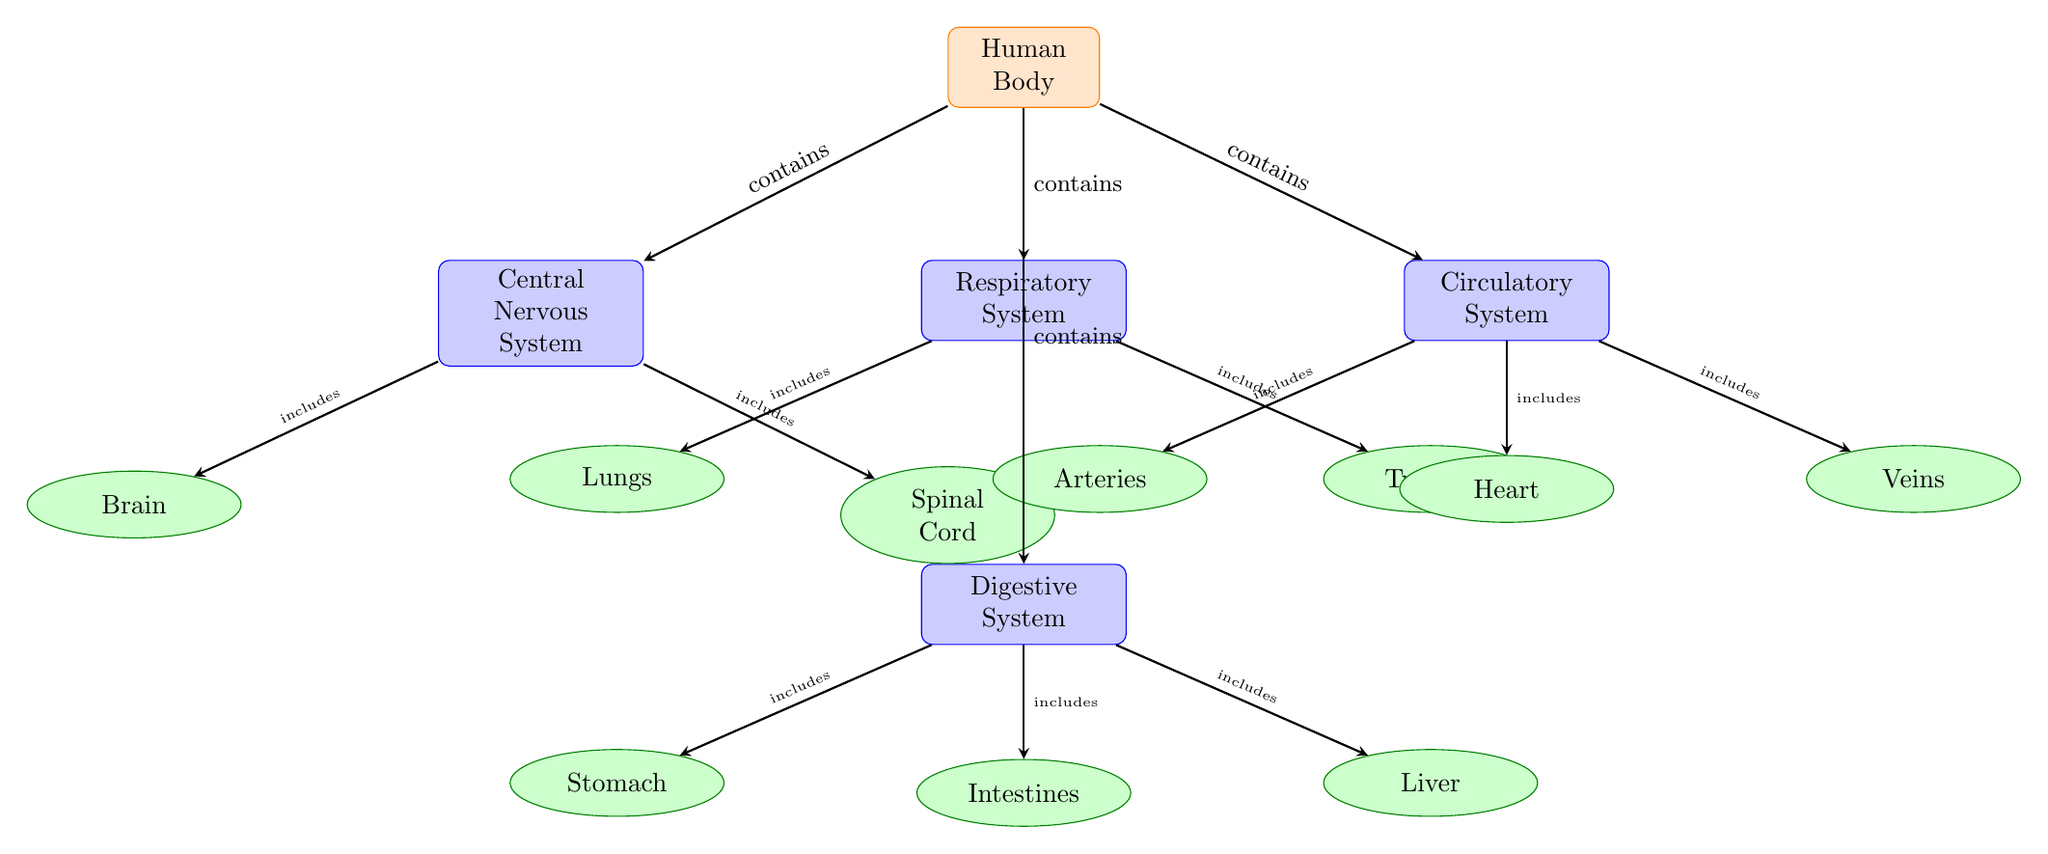What organ is included in the Central Nervous System? The diagram shows that the Central Nervous System includes both the Brain and the Spinal Cord. Since the question asks for one specific organ, we can refer to the Brain, which is explicitly listed as a component.
Answer: Brain How many organ systems are represented in the diagram? By counting the labeled organ systems in the diagram, we can see there are four: Central Nervous System, Respiratory System, Circulatory System, and Digestive System. Thus, the total is four organ systems.
Answer: 4 What organ is connected to the Respiratory System? The diagram indicates that the Respiratory System includes both the Lungs and the Trachea. Therefore, either of those could be answered, but we will specify Lungs as one connected organ.
Answer: Lungs What is the relationship between the Circulatory System and the Heart? The arrow from the Circulatory System to the Heart labeled 'includes' signifies that the Heart is an organ that is part of the Circulatory System. This relationship indicates that the Heart is one of the components included.
Answer: includes Which organ system contains the Stomach? The diagram shows that the Stomach is part of the Digestive System as represented by the arrow pointing from Digestive System to Stomach labeled 'includes.' This indicates clearly that the Stomach falls under the Digestive System.
Answer: Digestive System What is the total number of organs shown in the diagram? To find the total number of organs, we must count the organs labeled under each organ system. The numbers are as follows: 2 under CNS, 2 under Respiratory, 3 under Circulatory, and 3 under Digestive, leading to a total of 10 organs displayed in the diagram.
Answer: 10 What organ system does the Spinal Cord belong to? The diagram explicitly states that the Spinal Cord is included in the Central Nervous System, shown by the arrow directing from Central Nervous System to Spinal Cord labeled 'includes.' This defines the Spinal Cord's affiliation.
Answer: Central Nervous System Which organ is part of both the Circulatory System and the Digestive System? The diagram illustrates distinct organ systems, where the Heart belongs exclusively to the Circulatory System and the Stomach and Intestines to the Digestive System. No organ is shared between those two systems in this diagram since they are defined separately.
Answer: None 